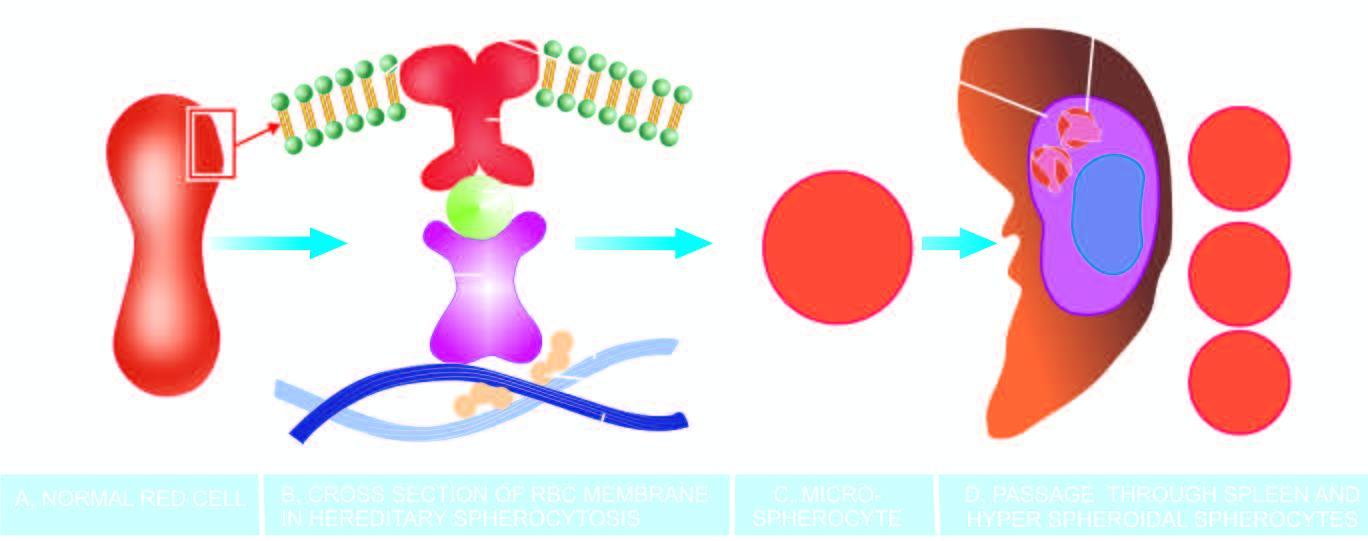what lose their cell membrane further during passage through the spleen?
Answer the question using a single word or phrase. These rigid spherical cells 